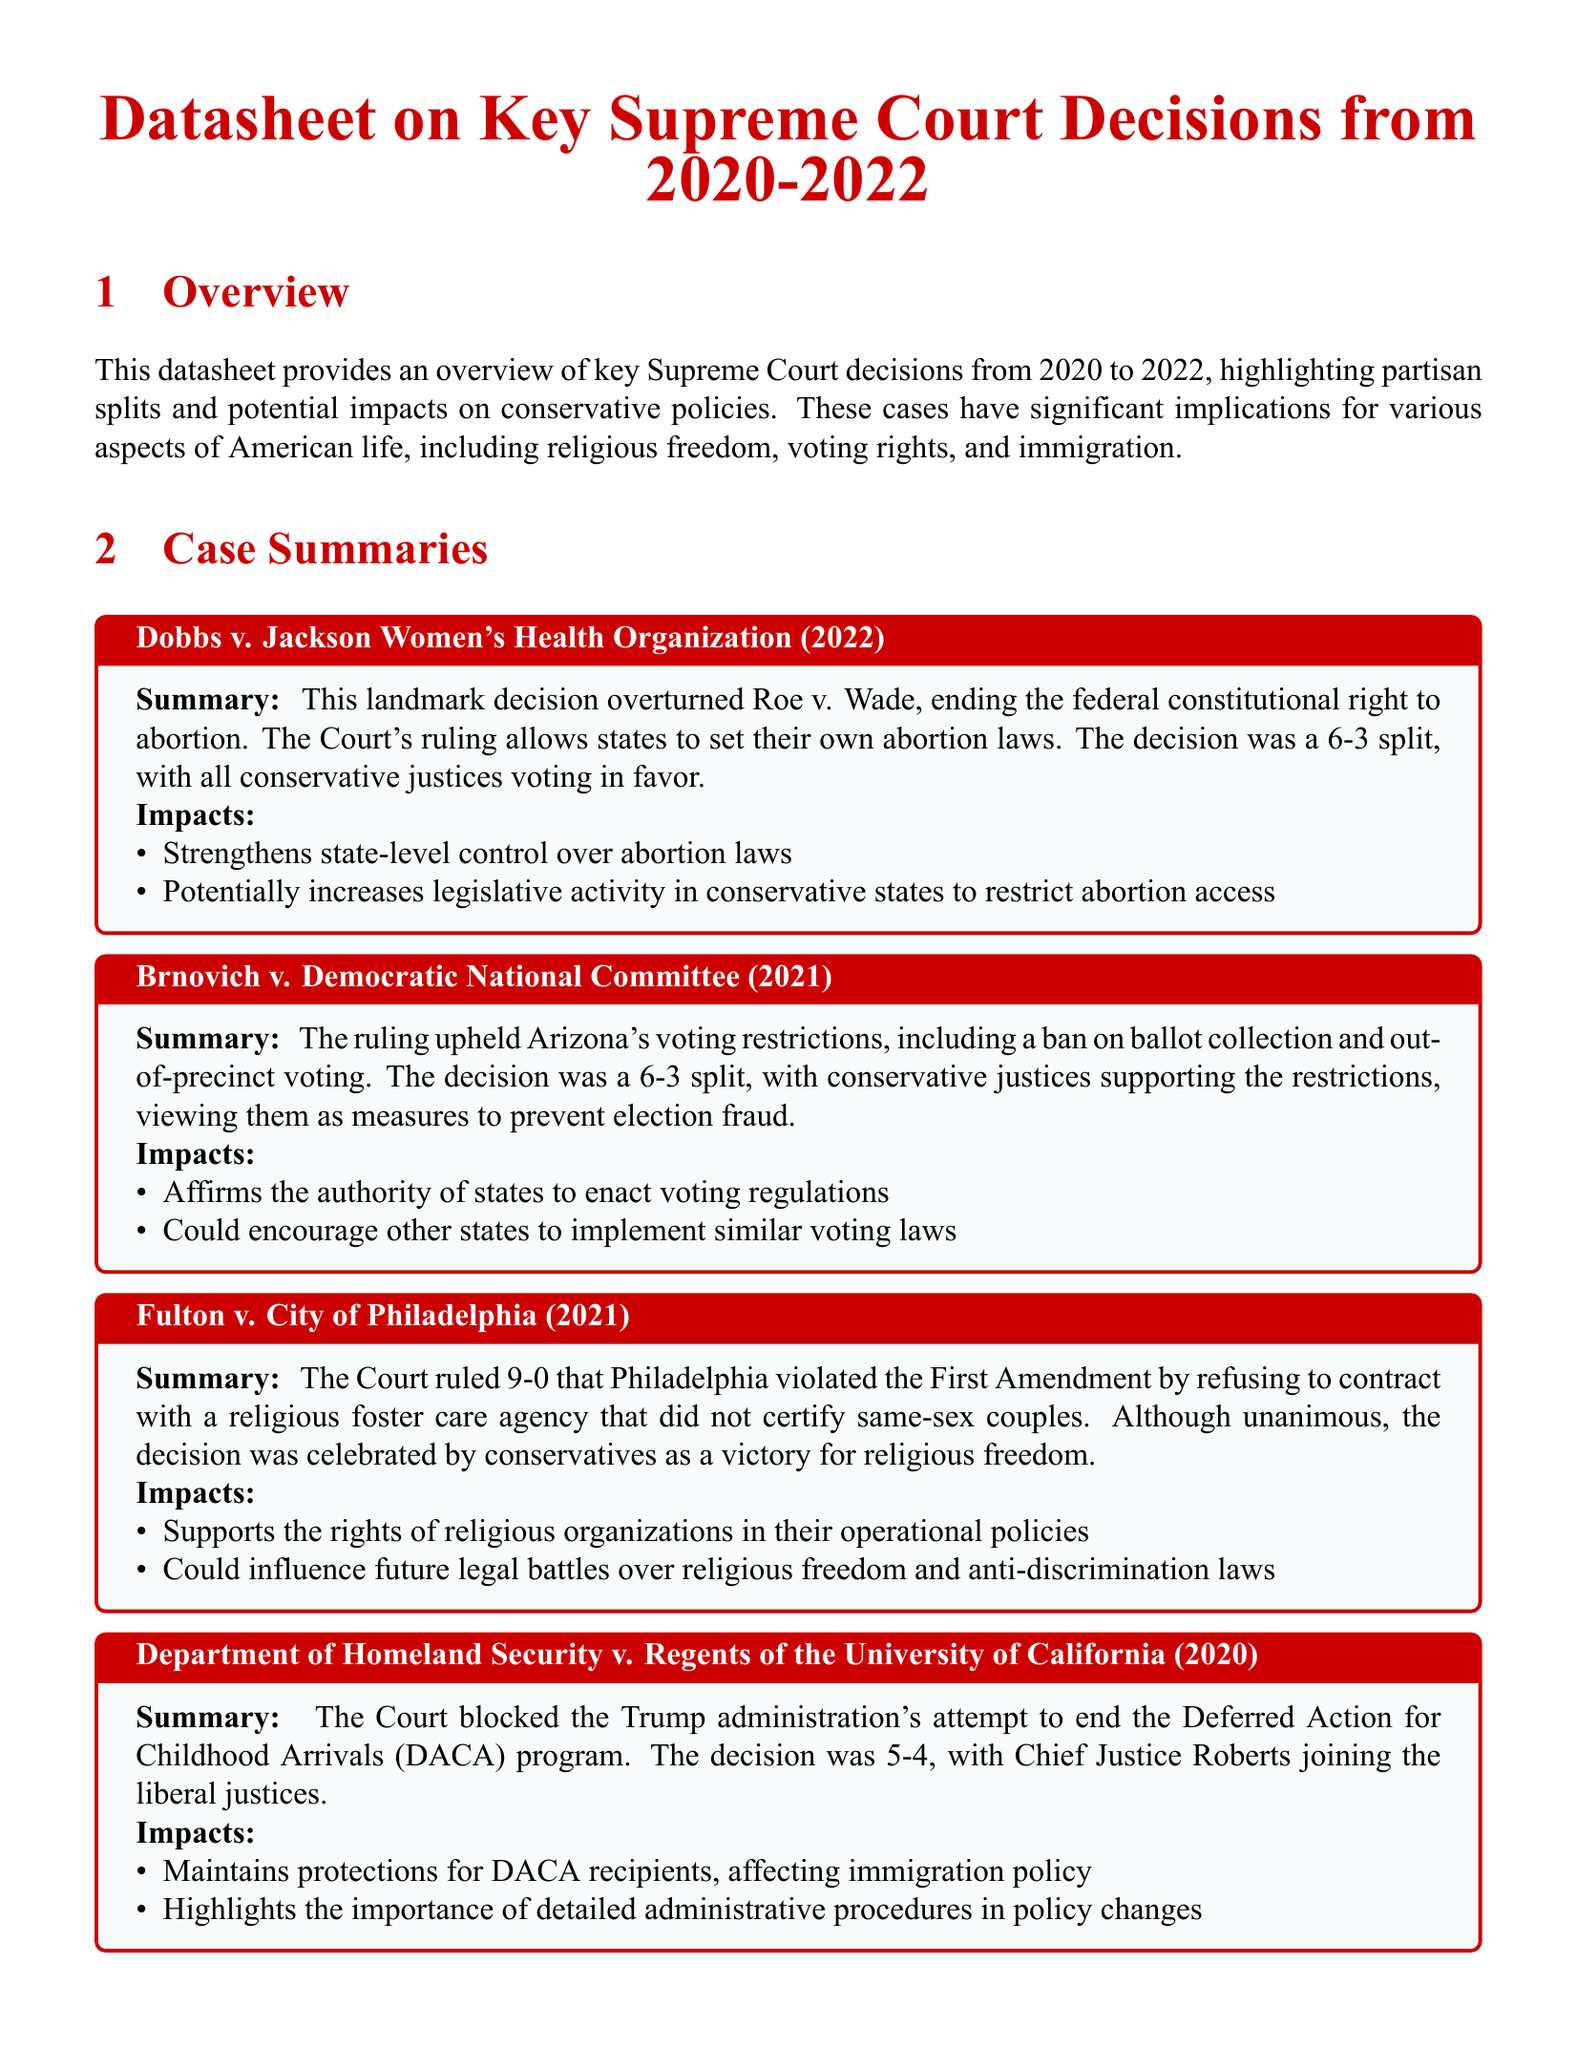What is the case name that overturned Roe v. Wade? The case name associated with overturning Roe v. Wade is Dobbs v. Jackson Women's Health Organization.
Answer: Dobbs v. Jackson Women's Health Organization How many justices voted in favor of the decision in Fulton v. City of Philadelphia? The case Fulton v. City of Philadelphia was decided unanimously, meaning all justices voted in favor.
Answer: 9 What impact does the Brnovich v. Democratic National Committee ruling have on voting regulations? The ruling affirms the authority of states to enact voting regulations, which can include various voting restrictions.
Answer: Authority to enact voting regulations Which program's end was blocked by the Court in the case of Department of Homeland Security v. Regents of the University of California? The program that was attempted to be ended and was blocked is the Deferred Action for Childhood Arrivals (DACA) program.
Answer: Deferred Action for Childhood Arrivals What principle was highlighted by the Court's decision in the case involving DACA? The decision emphasized the importance of detailed administrative procedures in policy changes.
Answer: Importance of detailed administrative procedures In which year was the Brnovich v. Democratic National Committee decision made? The case Brnovich v. Democratic National Committee was decided in 2021.
Answer: 2021 